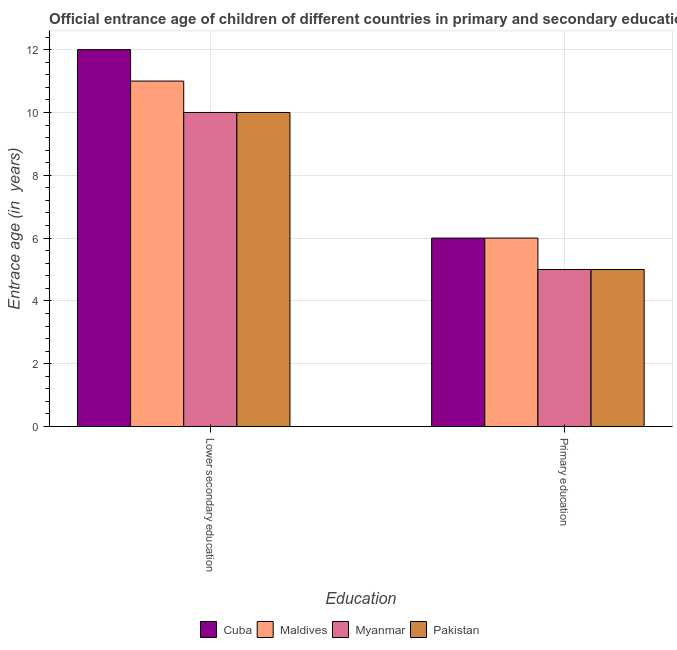How many different coloured bars are there?
Provide a short and direct response. 4. How many groups of bars are there?
Give a very brief answer. 2. How many bars are there on the 2nd tick from the right?
Offer a terse response. 4. What is the label of the 2nd group of bars from the left?
Your answer should be very brief. Primary education. What is the entrance age of children in lower secondary education in Cuba?
Your answer should be very brief. 12. Across all countries, what is the maximum entrance age of children in lower secondary education?
Give a very brief answer. 12. Across all countries, what is the minimum entrance age of chiildren in primary education?
Provide a short and direct response. 5. In which country was the entrance age of children in lower secondary education maximum?
Offer a very short reply. Cuba. In which country was the entrance age of children in lower secondary education minimum?
Ensure brevity in your answer.  Myanmar. What is the total entrance age of chiildren in primary education in the graph?
Give a very brief answer. 22. What is the difference between the entrance age of children in lower secondary education in Pakistan and that in Maldives?
Offer a terse response. -1. What is the difference between the entrance age of chiildren in primary education in Myanmar and the entrance age of children in lower secondary education in Pakistan?
Provide a short and direct response. -5. What is the average entrance age of chiildren in primary education per country?
Give a very brief answer. 5.5. What is the difference between the entrance age of chiildren in primary education and entrance age of children in lower secondary education in Maldives?
Provide a succinct answer. -5. In how many countries, is the entrance age of children in lower secondary education greater than 10.4 years?
Offer a very short reply. 2. What does the 3rd bar from the left in Lower secondary education represents?
Your answer should be compact. Myanmar. What does the 3rd bar from the right in Lower secondary education represents?
Offer a very short reply. Maldives. How many bars are there?
Your answer should be very brief. 8. Are all the bars in the graph horizontal?
Ensure brevity in your answer.  No. What is the difference between two consecutive major ticks on the Y-axis?
Your answer should be compact. 2. Does the graph contain grids?
Provide a succinct answer. Yes. How many legend labels are there?
Provide a succinct answer. 4. How are the legend labels stacked?
Your answer should be very brief. Horizontal. What is the title of the graph?
Your answer should be compact. Official entrance age of children of different countries in primary and secondary education. What is the label or title of the X-axis?
Your answer should be compact. Education. What is the label or title of the Y-axis?
Your response must be concise. Entrace age (in  years). What is the Entrace age (in  years) of Cuba in Lower secondary education?
Ensure brevity in your answer.  12. What is the Entrace age (in  years) in Maldives in Lower secondary education?
Keep it short and to the point. 11. What is the Entrace age (in  years) in Myanmar in Lower secondary education?
Ensure brevity in your answer.  10. What is the Entrace age (in  years) of Cuba in Primary education?
Provide a succinct answer. 6. What is the Entrace age (in  years) in Myanmar in Primary education?
Offer a terse response. 5. Across all Education, what is the maximum Entrace age (in  years) in Maldives?
Give a very brief answer. 11. Across all Education, what is the maximum Entrace age (in  years) of Myanmar?
Ensure brevity in your answer.  10. Across all Education, what is the minimum Entrace age (in  years) of Myanmar?
Provide a short and direct response. 5. What is the total Entrace age (in  years) in Cuba in the graph?
Offer a terse response. 18. What is the total Entrace age (in  years) in Maldives in the graph?
Your answer should be very brief. 17. What is the difference between the Entrace age (in  years) in Maldives in Lower secondary education and that in Primary education?
Your answer should be very brief. 5. What is the difference between the Entrace age (in  years) in Cuba in Lower secondary education and the Entrace age (in  years) in Maldives in Primary education?
Your response must be concise. 6. What is the difference between the Entrace age (in  years) of Cuba in Lower secondary education and the Entrace age (in  years) of Myanmar in Primary education?
Provide a succinct answer. 7. What is the difference between the Entrace age (in  years) of Cuba in Lower secondary education and the Entrace age (in  years) of Pakistan in Primary education?
Make the answer very short. 7. What is the difference between the Entrace age (in  years) of Myanmar in Lower secondary education and the Entrace age (in  years) of Pakistan in Primary education?
Your answer should be very brief. 5. What is the average Entrace age (in  years) of Maldives per Education?
Offer a very short reply. 8.5. What is the difference between the Entrace age (in  years) in Cuba and Entrace age (in  years) in Pakistan in Lower secondary education?
Your answer should be compact. 2. What is the difference between the Entrace age (in  years) in Maldives and Entrace age (in  years) in Myanmar in Lower secondary education?
Ensure brevity in your answer.  1. What is the difference between the Entrace age (in  years) in Maldives and Entrace age (in  years) in Pakistan in Lower secondary education?
Ensure brevity in your answer.  1. What is the difference between the Entrace age (in  years) in Myanmar and Entrace age (in  years) in Pakistan in Lower secondary education?
Provide a succinct answer. 0. What is the difference between the Entrace age (in  years) of Cuba and Entrace age (in  years) of Maldives in Primary education?
Your answer should be compact. 0. What is the ratio of the Entrace age (in  years) in Maldives in Lower secondary education to that in Primary education?
Ensure brevity in your answer.  1.83. What is the ratio of the Entrace age (in  years) of Myanmar in Lower secondary education to that in Primary education?
Give a very brief answer. 2. What is the ratio of the Entrace age (in  years) of Pakistan in Lower secondary education to that in Primary education?
Keep it short and to the point. 2. What is the difference between the highest and the second highest Entrace age (in  years) in Cuba?
Provide a short and direct response. 6. What is the difference between the highest and the second highest Entrace age (in  years) of Maldives?
Offer a very short reply. 5. What is the difference between the highest and the second highest Entrace age (in  years) of Myanmar?
Keep it short and to the point. 5. What is the difference between the highest and the lowest Entrace age (in  years) of Maldives?
Keep it short and to the point. 5. 